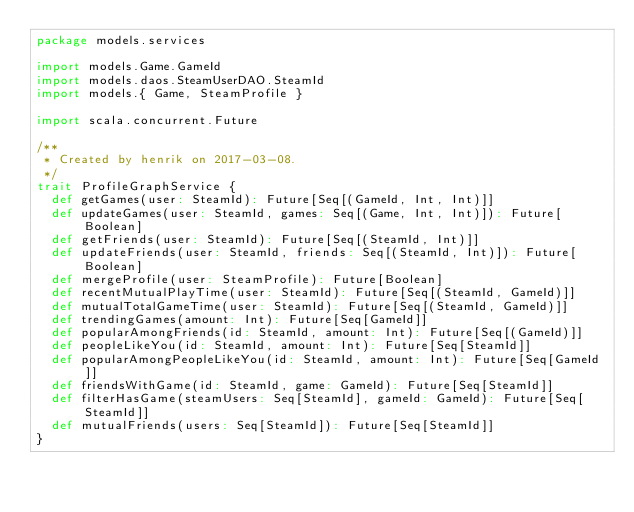Convert code to text. <code><loc_0><loc_0><loc_500><loc_500><_Scala_>package models.services

import models.Game.GameId
import models.daos.SteamUserDAO.SteamId
import models.{ Game, SteamProfile }

import scala.concurrent.Future

/**
 * Created by henrik on 2017-03-08.
 */
trait ProfileGraphService {
  def getGames(user: SteamId): Future[Seq[(GameId, Int, Int)]]
  def updateGames(user: SteamId, games: Seq[(Game, Int, Int)]): Future[Boolean]
  def getFriends(user: SteamId): Future[Seq[(SteamId, Int)]]
  def updateFriends(user: SteamId, friends: Seq[(SteamId, Int)]): Future[Boolean]
  def mergeProfile(user: SteamProfile): Future[Boolean]
  def recentMutualPlayTime(user: SteamId): Future[Seq[(SteamId, GameId)]]
  def mutualTotalGameTime(user: SteamId): Future[Seq[(SteamId, GameId)]]
  def trendingGames(amount: Int): Future[Seq[GameId]]
  def popularAmongFriends(id: SteamId, amount: Int): Future[Seq[(GameId)]]
  def peopleLikeYou(id: SteamId, amount: Int): Future[Seq[SteamId]]
  def popularAmongPeopleLikeYou(id: SteamId, amount: Int): Future[Seq[GameId]]
  def friendsWithGame(id: SteamId, game: GameId): Future[Seq[SteamId]]
  def filterHasGame(steamUsers: Seq[SteamId], gameId: GameId): Future[Seq[SteamId]]
  def mutualFriends(users: Seq[SteamId]): Future[Seq[SteamId]]
}</code> 